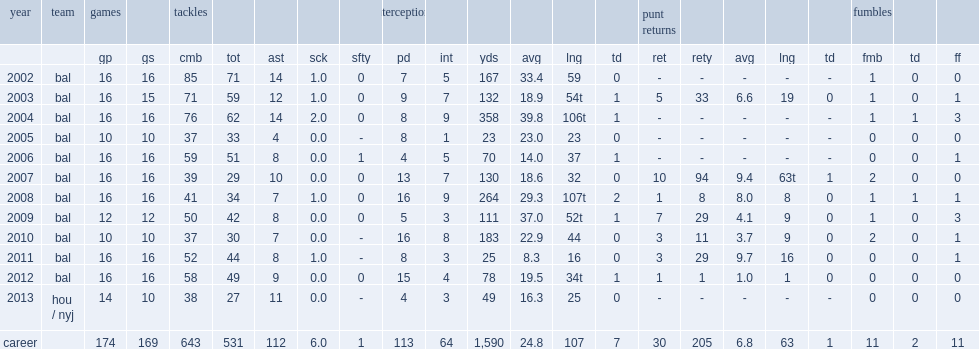What was the number of yards on nine interceptions reed got in 2004? 358.0. 